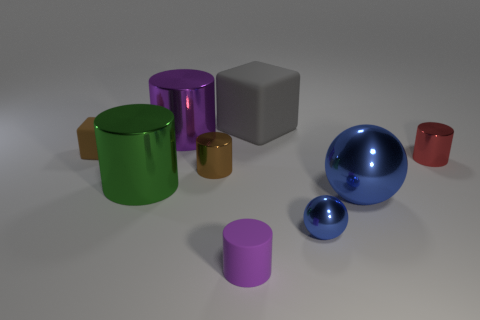Is there any other thing of the same color as the rubber cylinder?
Make the answer very short. Yes. How many tiny gray metallic cylinders are there?
Give a very brief answer. 0. There is a small shiny thing that is both left of the large metal ball and behind the green metal cylinder; what is its shape?
Keep it short and to the point. Cylinder. The purple thing that is behind the rubber block in front of the big gray matte block on the left side of the big blue metallic thing is what shape?
Keep it short and to the point. Cylinder. The large thing that is in front of the big gray object and behind the large green cylinder is made of what material?
Your answer should be compact. Metal. How many red objects are the same size as the purple matte cylinder?
Provide a short and direct response. 1. How many matte things are either large spheres or large objects?
Your response must be concise. 1. What material is the small red thing?
Offer a terse response. Metal. There is a gray matte cube; what number of metal objects are on the right side of it?
Offer a terse response. 3. Are the large cylinder in front of the large purple metal object and the brown cylinder made of the same material?
Ensure brevity in your answer.  Yes. 